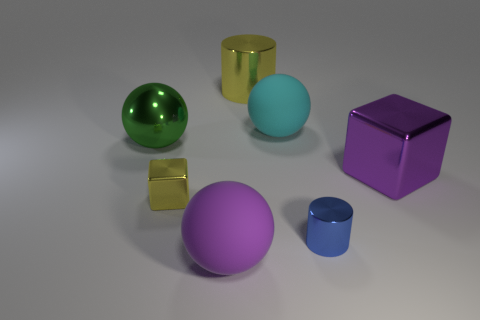Add 3 big green blocks. How many objects exist? 10 Subtract all blocks. How many objects are left? 5 Subtract 1 cyan spheres. How many objects are left? 6 Subtract all purple rubber objects. Subtract all big purple rubber objects. How many objects are left? 5 Add 3 large yellow metallic cylinders. How many large yellow metallic cylinders are left? 4 Add 6 small blocks. How many small blocks exist? 7 